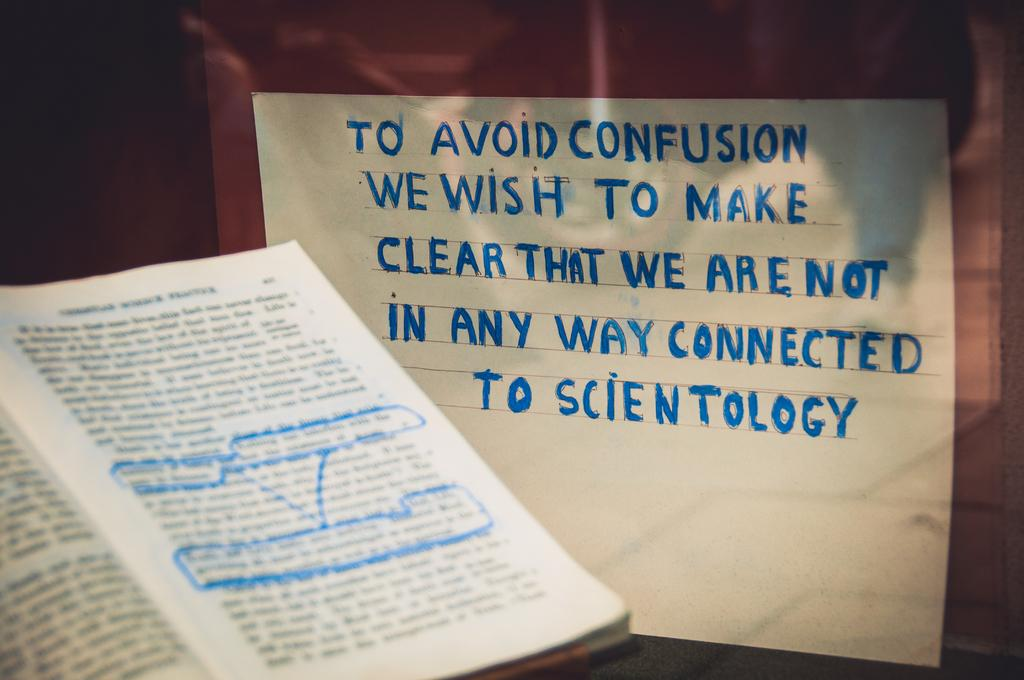<image>
Summarize the visual content of the image. White sign that says to avoid confusion we wish to make clear that we are not in any way connected to scientology. 